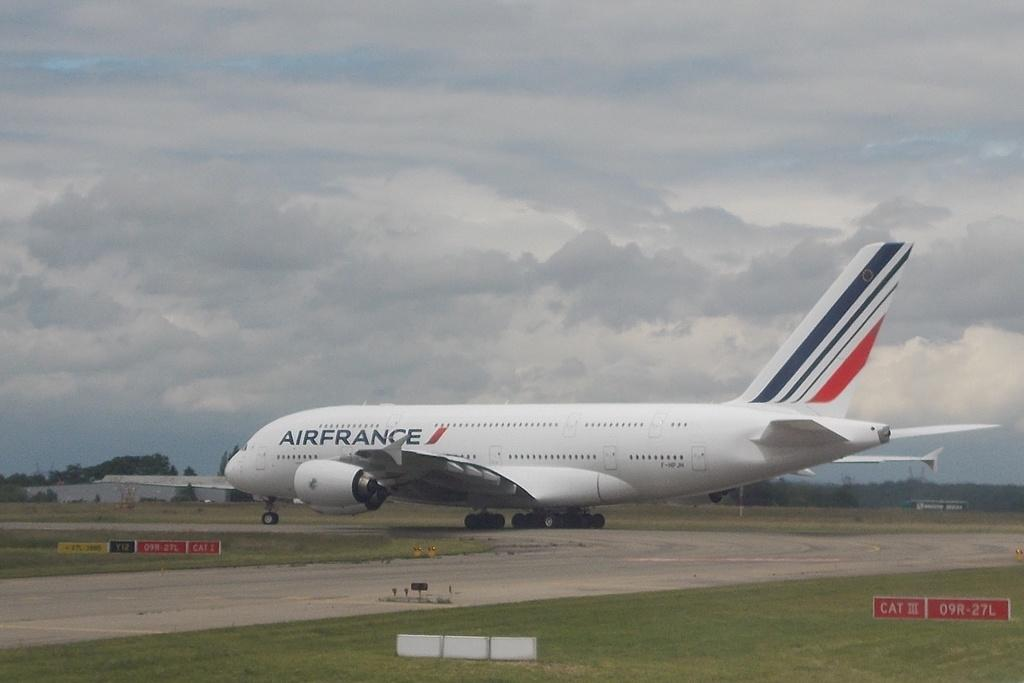<image>
Share a concise interpretation of the image provided. An Air France aircraft rolls past the CAT III and CAT I signs on the ground. 